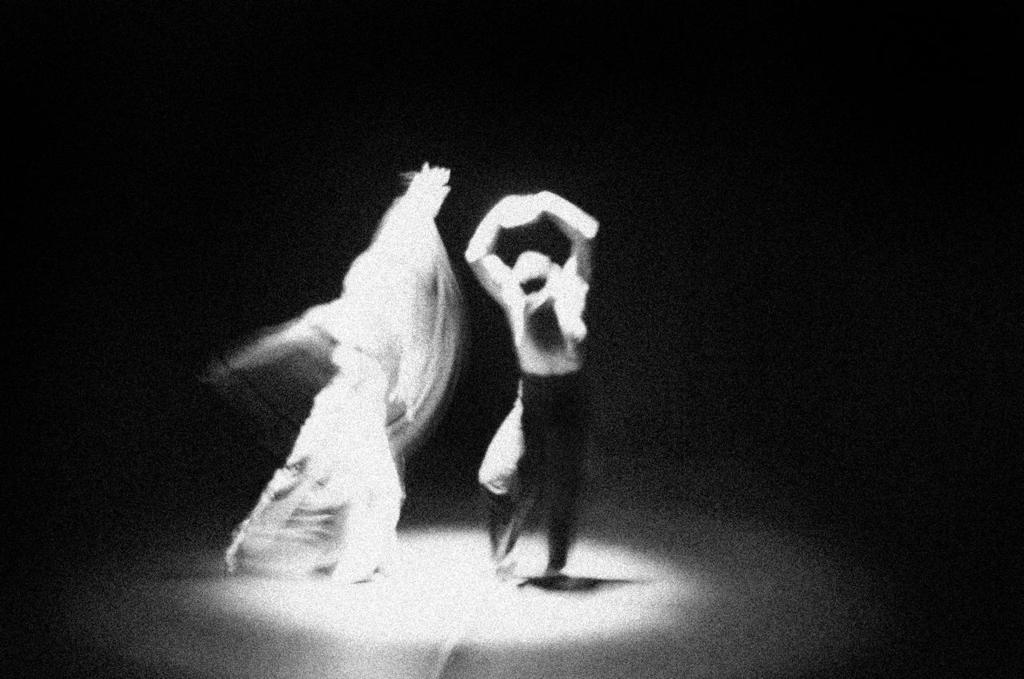How many people are in the image? There are two persons in the image. What are the two persons doing in the image? The two persons are dancing. Can you describe the quality of the image? The image is blurred. What type of advertisement is displayed on the wall behind the dancers in the image? There is no advertisement or wall visible in the image; it only shows two persons dancing. 